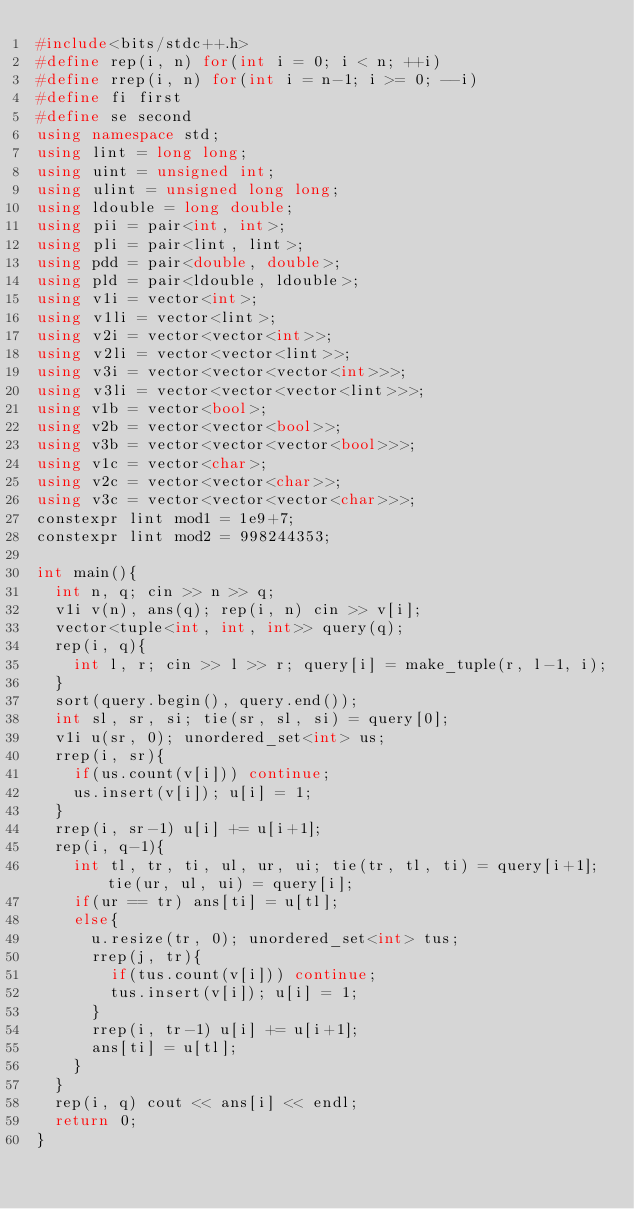Convert code to text. <code><loc_0><loc_0><loc_500><loc_500><_C++_>#include<bits/stdc++.h>
#define rep(i, n) for(int i = 0; i < n; ++i)
#define rrep(i, n) for(int i = n-1; i >= 0; --i)
#define fi first
#define se second
using namespace std;
using lint = long long;
using uint = unsigned int;
using ulint = unsigned long long;
using ldouble = long double;
using pii = pair<int, int>;
using pli = pair<lint, lint>;
using pdd = pair<double, double>;
using pld = pair<ldouble, ldouble>;
using v1i = vector<int>;
using v1li = vector<lint>;
using v2i = vector<vector<int>>;
using v2li = vector<vector<lint>>;
using v3i = vector<vector<vector<int>>>;
using v3li = vector<vector<vector<lint>>>;
using v1b = vector<bool>;
using v2b = vector<vector<bool>>;
using v3b = vector<vector<vector<bool>>>;
using v1c = vector<char>;
using v2c = vector<vector<char>>;
using v3c = vector<vector<vector<char>>>;
constexpr lint mod1 = 1e9+7;
constexpr lint mod2 = 998244353;

int main(){
  int n, q; cin >> n >> q;
  v1i v(n), ans(q); rep(i, n) cin >> v[i];
  vector<tuple<int, int, int>> query(q);
  rep(i, q){
    int l, r; cin >> l >> r; query[i] = make_tuple(r, l-1, i);
  }
  sort(query.begin(), query.end());
  int sl, sr, si; tie(sr, sl, si) = query[0];
  v1i u(sr, 0); unordered_set<int> us;
  rrep(i, sr){
    if(us.count(v[i])) continue;
    us.insert(v[i]); u[i] = 1;
  }
  rrep(i, sr-1) u[i] += u[i+1];
  rep(i, q-1){
    int tl, tr, ti, ul, ur, ui; tie(tr, tl, ti) = query[i+1]; tie(ur, ul, ui) = query[i];
    if(ur == tr) ans[ti] = u[tl];
    else{
      u.resize(tr, 0); unordered_set<int> tus;
      rrep(j, tr){
        if(tus.count(v[i])) continue;
        tus.insert(v[i]); u[i] = 1;
      }
      rrep(i, tr-1) u[i] += u[i+1];
      ans[ti] = u[tl];
    }
  }
  rep(i, q) cout << ans[i] << endl;
  return 0;
}</code> 